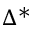Convert formula to latex. <formula><loc_0><loc_0><loc_500><loc_500>\Delta ^ { * }</formula> 